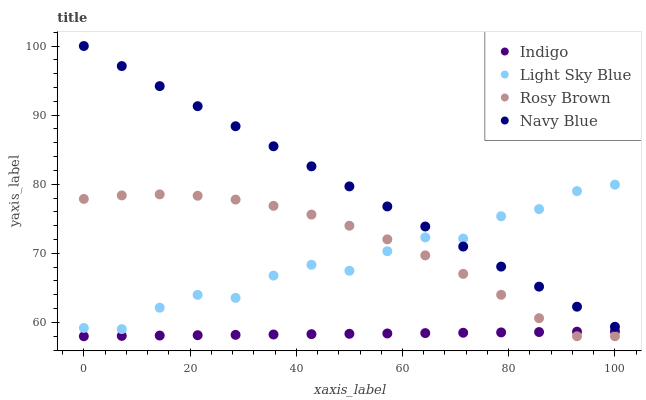Does Indigo have the minimum area under the curve?
Answer yes or no. Yes. Does Navy Blue have the maximum area under the curve?
Answer yes or no. Yes. Does Rosy Brown have the minimum area under the curve?
Answer yes or no. No. Does Rosy Brown have the maximum area under the curve?
Answer yes or no. No. Is Indigo the smoothest?
Answer yes or no. Yes. Is Light Sky Blue the roughest?
Answer yes or no. Yes. Is Rosy Brown the smoothest?
Answer yes or no. No. Is Rosy Brown the roughest?
Answer yes or no. No. Does Rosy Brown have the lowest value?
Answer yes or no. Yes. Does Light Sky Blue have the lowest value?
Answer yes or no. No. Does Navy Blue have the highest value?
Answer yes or no. Yes. Does Rosy Brown have the highest value?
Answer yes or no. No. Is Indigo less than Navy Blue?
Answer yes or no. Yes. Is Light Sky Blue greater than Indigo?
Answer yes or no. Yes. Does Indigo intersect Rosy Brown?
Answer yes or no. Yes. Is Indigo less than Rosy Brown?
Answer yes or no. No. Is Indigo greater than Rosy Brown?
Answer yes or no. No. Does Indigo intersect Navy Blue?
Answer yes or no. No. 